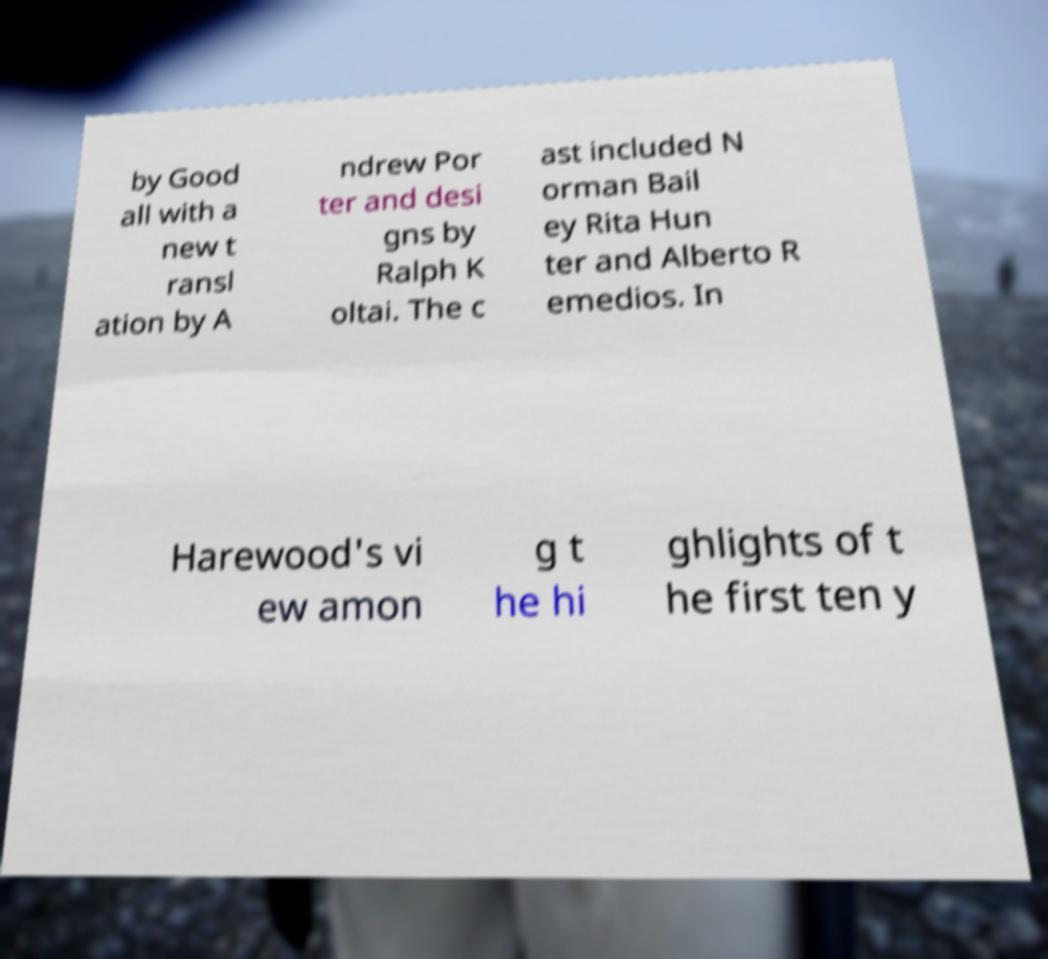There's text embedded in this image that I need extracted. Can you transcribe it verbatim? by Good all with a new t ransl ation by A ndrew Por ter and desi gns by Ralph K oltai. The c ast included N orman Bail ey Rita Hun ter and Alberto R emedios. In Harewood's vi ew amon g t he hi ghlights of t he first ten y 